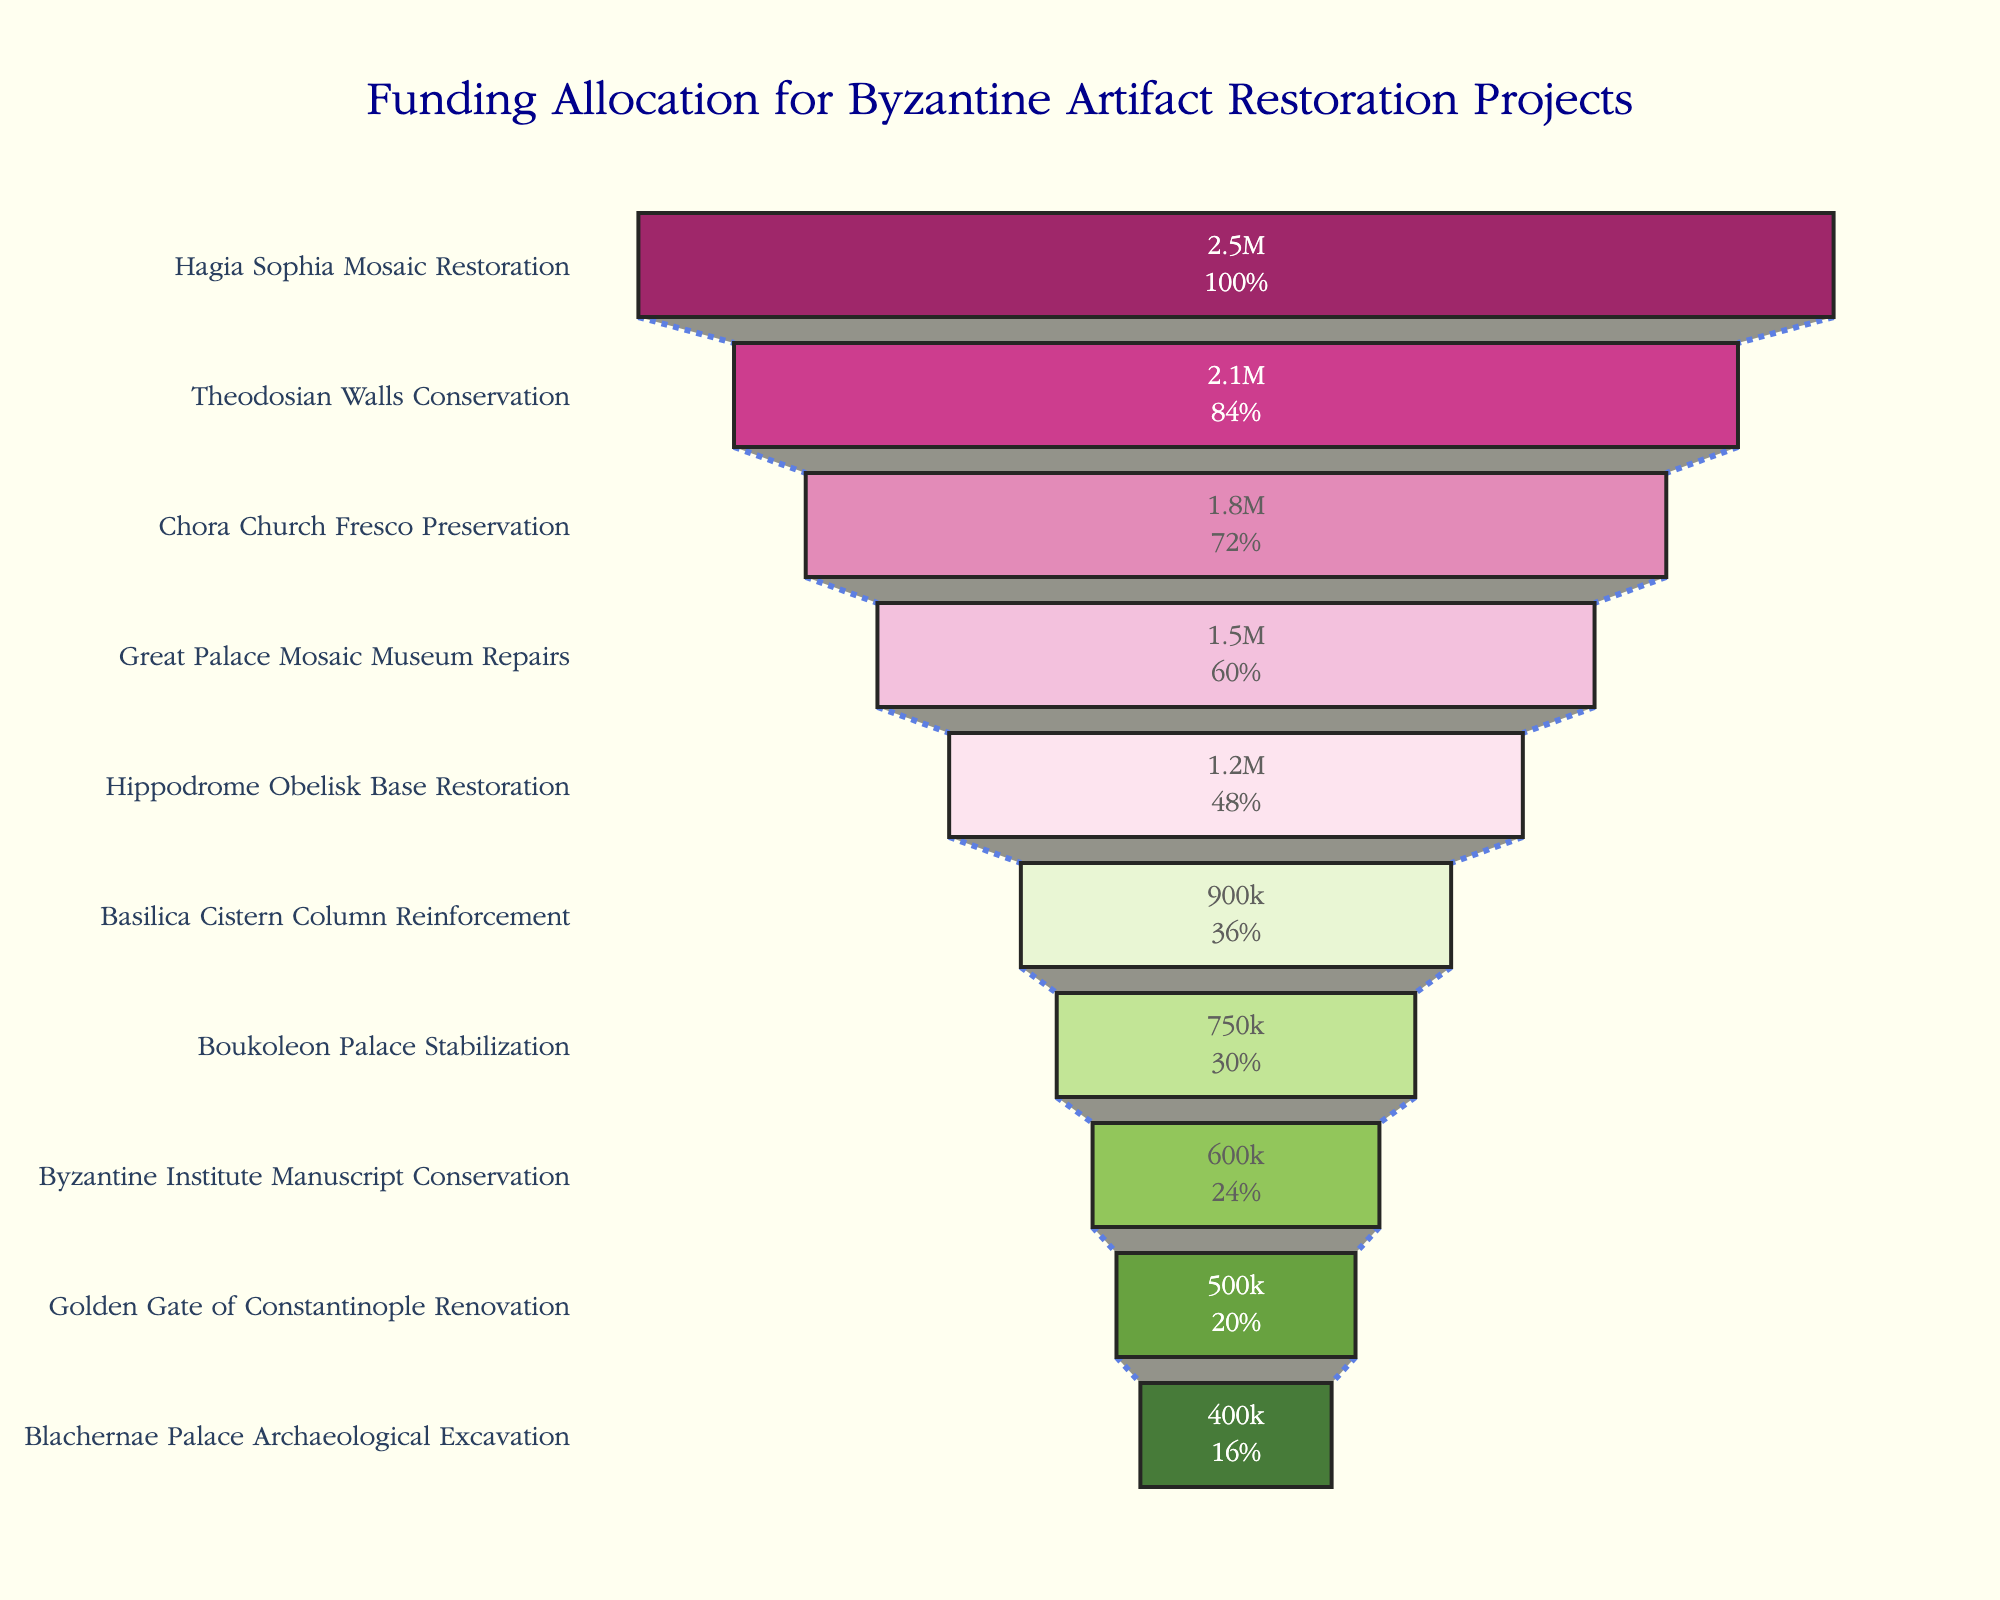what is the title of the funnel chart? The title is located at the top center of the chart; it gives an overview or summary of the content presented in the funnel chart.
Answer: Funding Allocation for Byzantine Artifact Restoration Projects How many projects are displayed in the funnel chart? Count the number of sections or layers in the funnel chart to enumerate the projects.
Answer: 10 Which project received the most funding? Identify the project at the top of the funnel since the funnel chart is sorted from highest to lowest funding.
Answer: Hagia Sophia Mosaic Restoration What is the total funding for the top three projects combined? Add the funding amounts of the top three projects: Hagia Sophia Mosaic Restoration ($2,500,000), Theodosian Walls Conservation ($2,100,000), and Chora Church Fresco Preservation ($1,800,000).
Answer: $6,400,000 Which project received less funding: Basilica Cistern Column Reinforcement or Boukoleon Palace Stabilization? Locate both projects in the funnel chart and compare their positions and funding amounts.
Answer: Boukoleon Palace Stabilization What percentage of the total funding does the Blachernae Palace Archaeological Excavation project receive? Calculate the proportion of the funding for Blachernae Palace Archaeological Excavation ($400,000) to the sum of all projects' funding, then convert it to a percentage. Sum = $12,200,000; Percentage = ($400,000/$12,200,000) * 100.
Answer: 3.28% How much more funding did the Great Palace Mosaic Museum Repairs receive compared to the Golden Gate of Constantinople Renovation? Subtract the funding for the Golden Gate of Constantinople Renovation ($500,000) from the funding for the Great Palace Mosaic Museum Repairs ($1,500,000).
Answer: $1,000,000 Is the funding for the Basilica Cistern Column Reinforcement more or less than half of the funding for the Hippodrome Obelisk Base Restoration? Calculate half of the funding for Hippodrome Obelisk Base Restoration ($1,200,000 / 2 = $600,000) and compare it to the funding for Basilica Cistern Column Reinforcement ($900,000).
Answer: More If you combined the funding of the last two projects, would it exceed the funding of the Byzantine Institute Manuscript Conservation project? Sum the funds for the last two projects: Golden Gate of Constantinople Renovation ($500,000) + Blachernae Palace Archaeological Excavation ($400,000) = $900,000 and compare it to the funding for Byzantine Institute Manuscript Conservation ($600,000).
Answer: Yes Which projects receive less than $1,000,000 in funding? Identify all projects in the funnel chart with funding amounts below $1,000,000.
Answer: Boukoleon Palace Stabilization, Byzantine Institute Manuscript Conservation, Golden Gate of Constantinople Renovation, Blachernae Palace Archaeological Excavation 